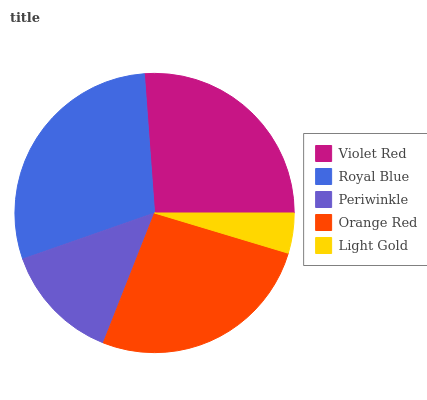Is Light Gold the minimum?
Answer yes or no. Yes. Is Royal Blue the maximum?
Answer yes or no. Yes. Is Periwinkle the minimum?
Answer yes or no. No. Is Periwinkle the maximum?
Answer yes or no. No. Is Royal Blue greater than Periwinkle?
Answer yes or no. Yes. Is Periwinkle less than Royal Blue?
Answer yes or no. Yes. Is Periwinkle greater than Royal Blue?
Answer yes or no. No. Is Royal Blue less than Periwinkle?
Answer yes or no. No. Is Violet Red the high median?
Answer yes or no. Yes. Is Violet Red the low median?
Answer yes or no. Yes. Is Royal Blue the high median?
Answer yes or no. No. Is Royal Blue the low median?
Answer yes or no. No. 